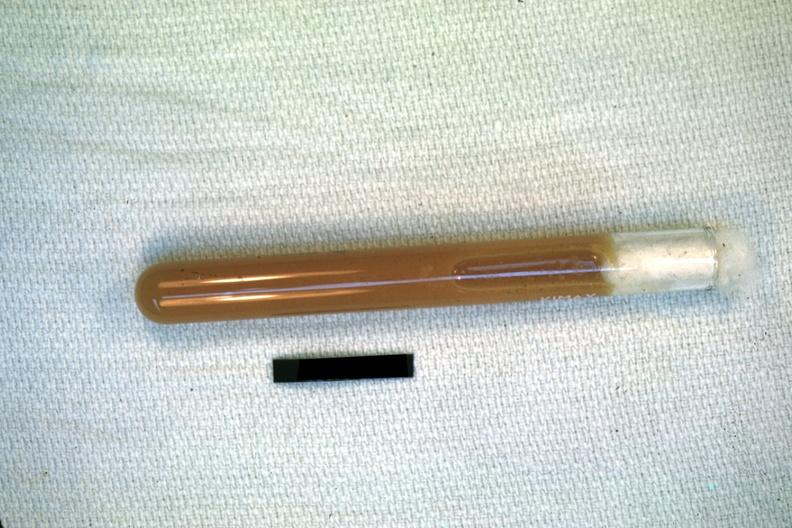where is this area in the body?
Answer the question using a single word or phrase. Abdomen 